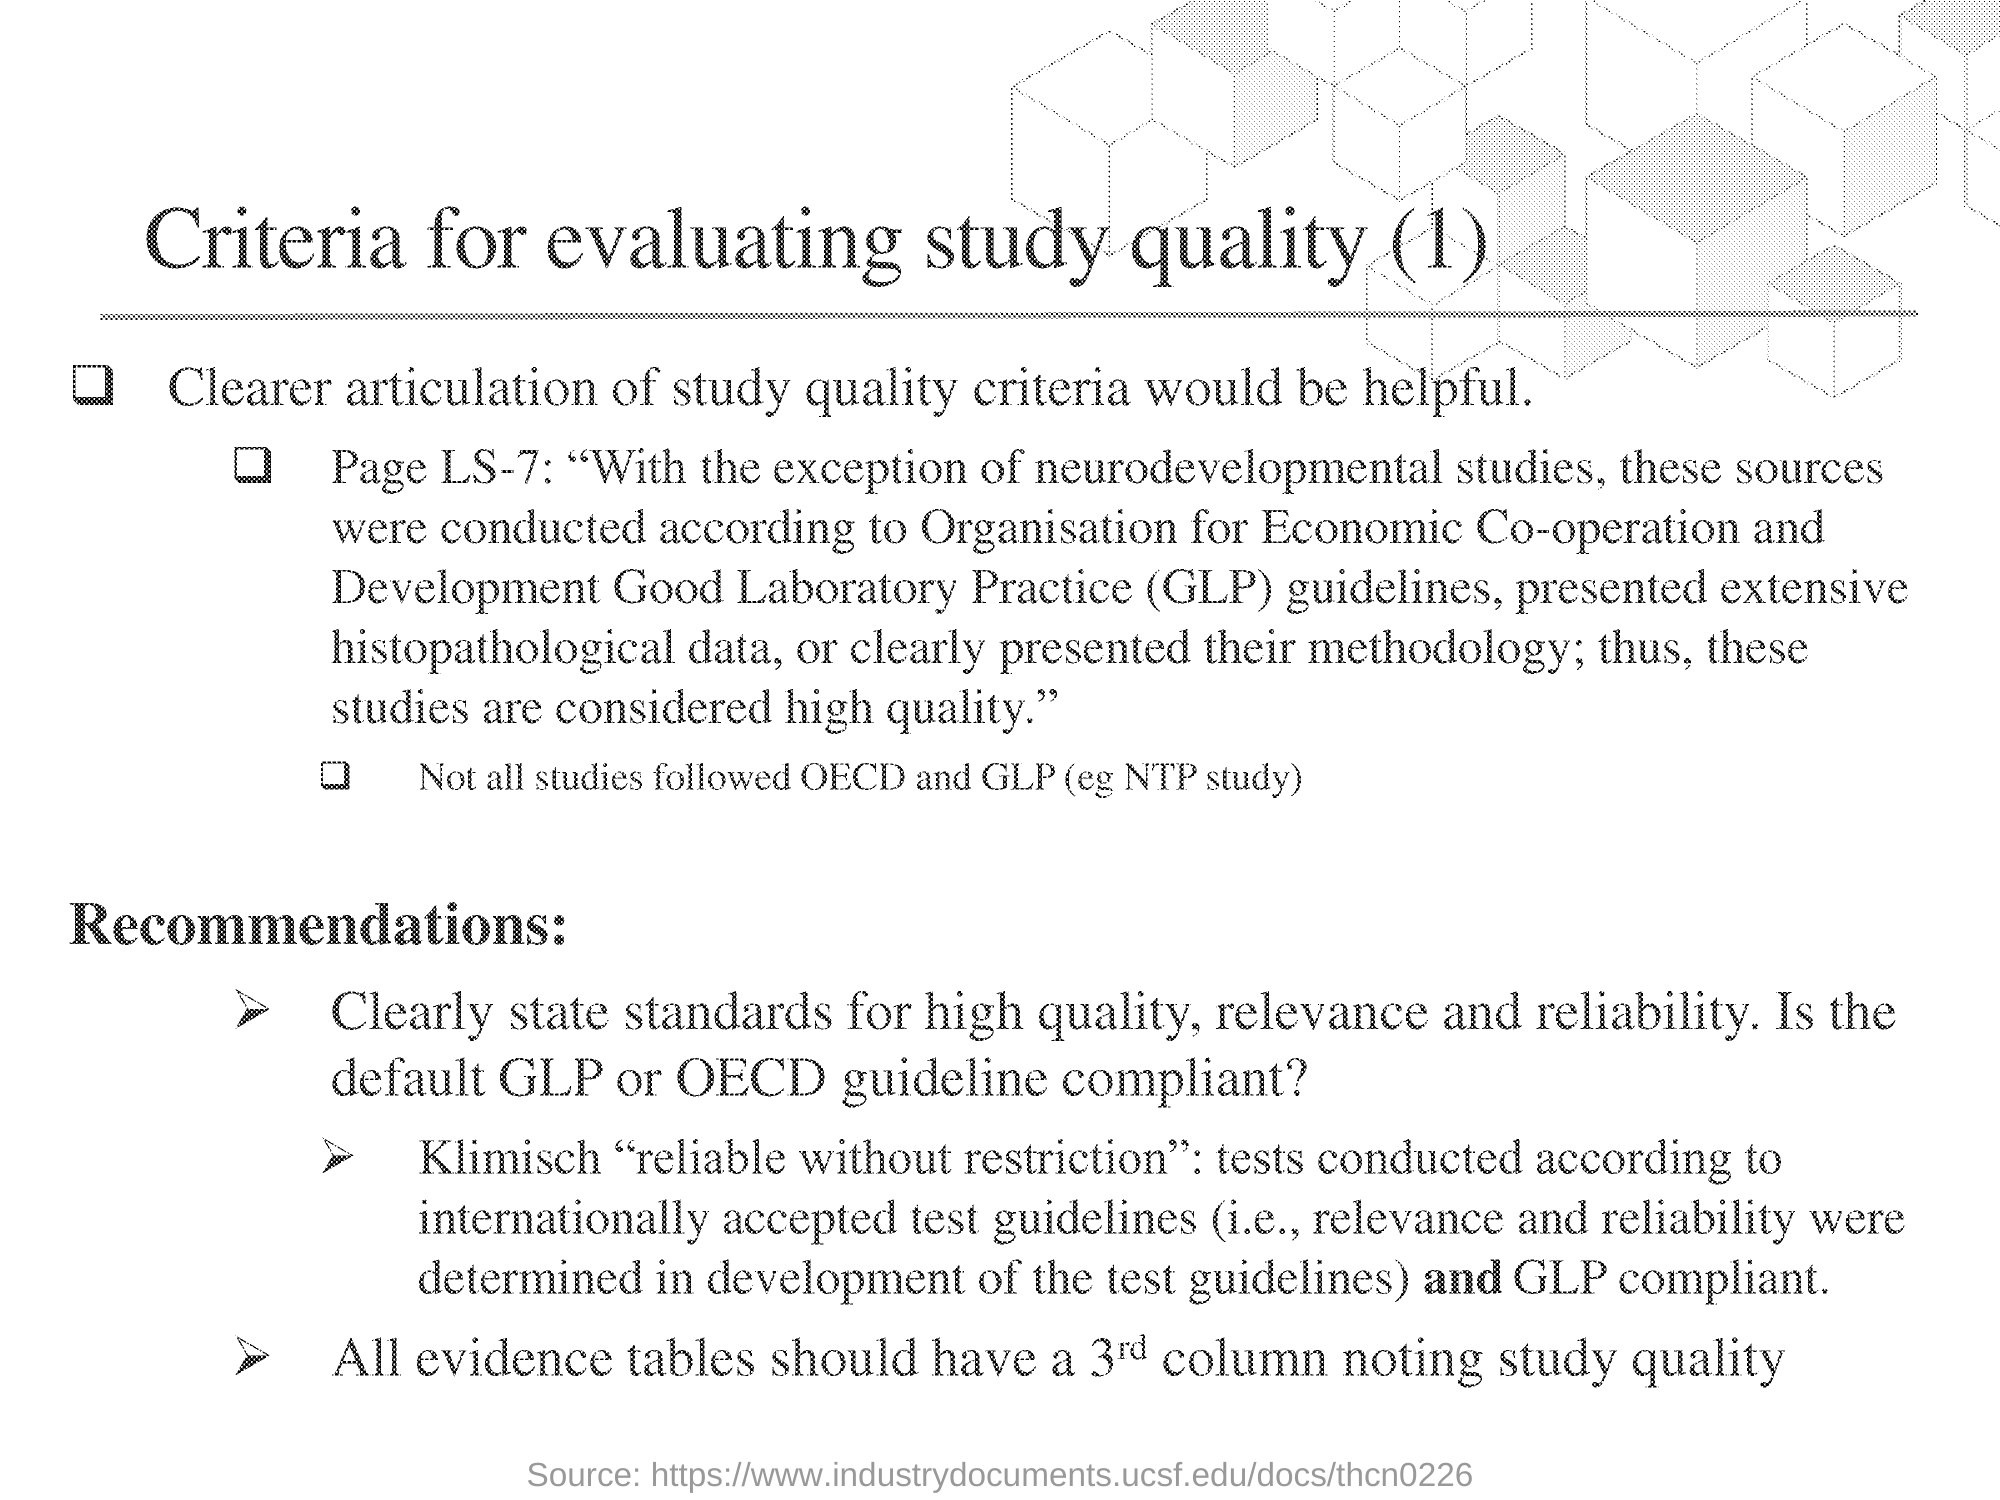What is the full form of GLP?
Your response must be concise. Good laboratory practice. What is the title of the document?
Offer a terse response. Criteria for evaluating study quality (1). 